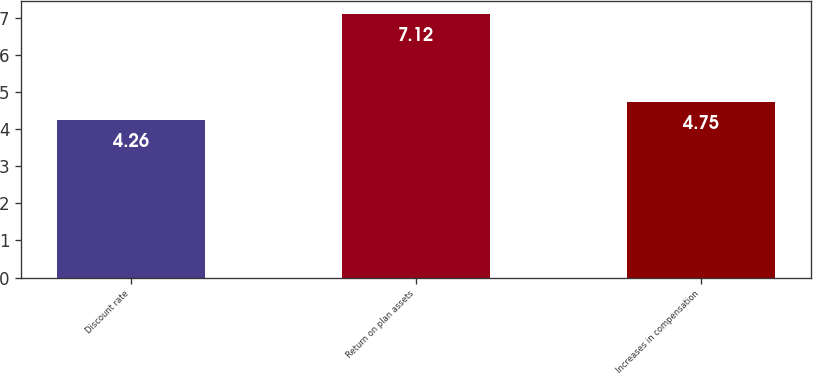<chart> <loc_0><loc_0><loc_500><loc_500><bar_chart><fcel>Discount rate<fcel>Return on plan assets<fcel>Increases in compensation<nl><fcel>4.26<fcel>7.12<fcel>4.75<nl></chart> 